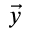Convert formula to latex. <formula><loc_0><loc_0><loc_500><loc_500>\vec { y }</formula> 